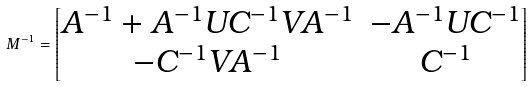Convert formula to latex. <formula><loc_0><loc_0><loc_500><loc_500>M ^ { - 1 } = \begin{bmatrix} A ^ { - 1 } + A ^ { - 1 } U C ^ { - 1 } V A ^ { - 1 } & - A ^ { - 1 } U C ^ { - 1 } \\ - C ^ { - 1 } V A ^ { - 1 } & C ^ { - 1 } \end{bmatrix}</formula> 